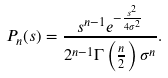<formula> <loc_0><loc_0><loc_500><loc_500>P _ { n } ( s ) = \frac { s ^ { n - 1 } e ^ { - \frac { s ^ { 2 } } { 4 \sigma ^ { 2 } } } } { 2 ^ { n - 1 } \Gamma \left ( \frac { n } { 2 } \right ) \sigma ^ { n } } .</formula> 